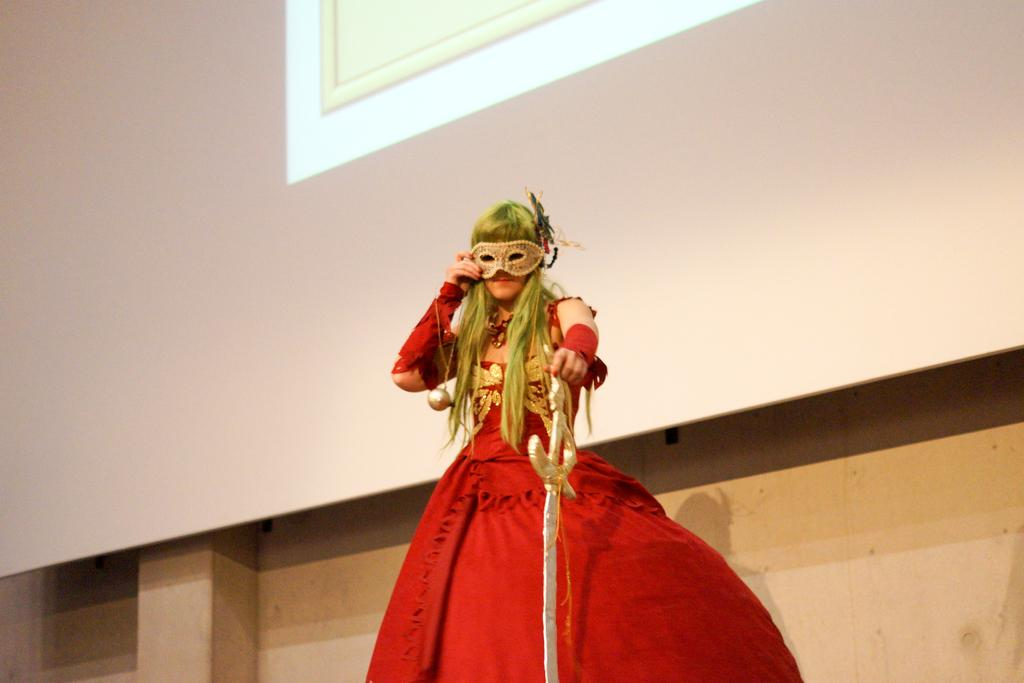Who is the main subject in the image? There is a lady in the image. What is the lady wearing? The lady is wearing a red frock. What is the lady holding in the image? The lady is holding a sword. What can be seen in the background of the image? There is a screen in the background of the image. What type of dust can be seen on the lady's shoes in the image? There is no dust visible on the lady's shoes in the image. What show is the lady attending in the image? There is no indication of a show or event in the image; the lady is simply holding a sword. 